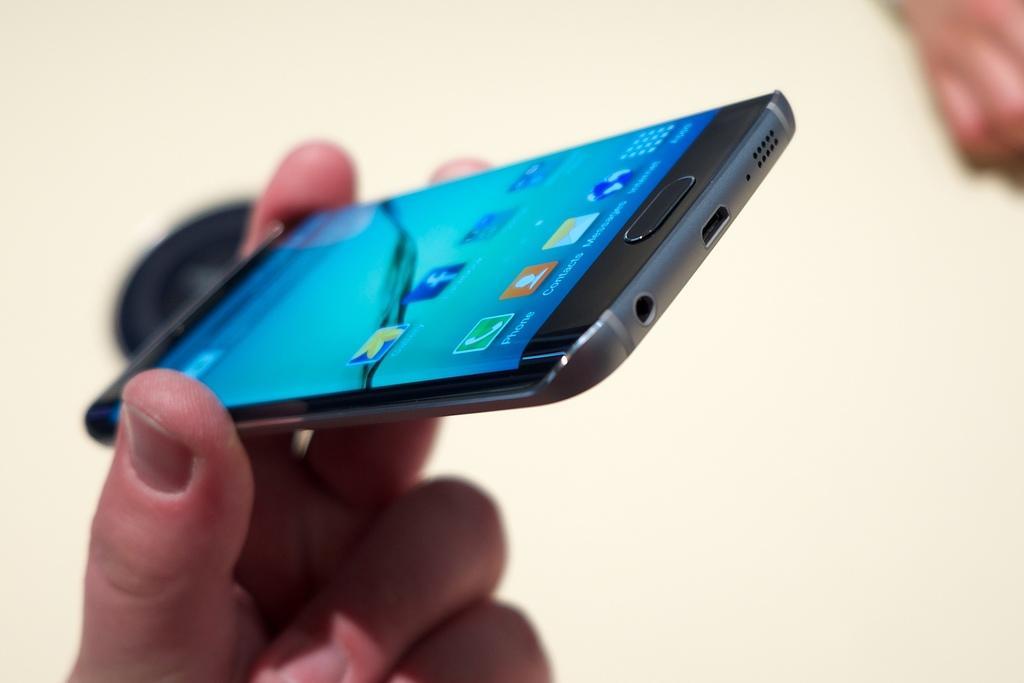Describe this image in one or two sentences. In this image we can see a human hand is holding mobile. On the screen of mobile, we can see icons. The background is white in color. 